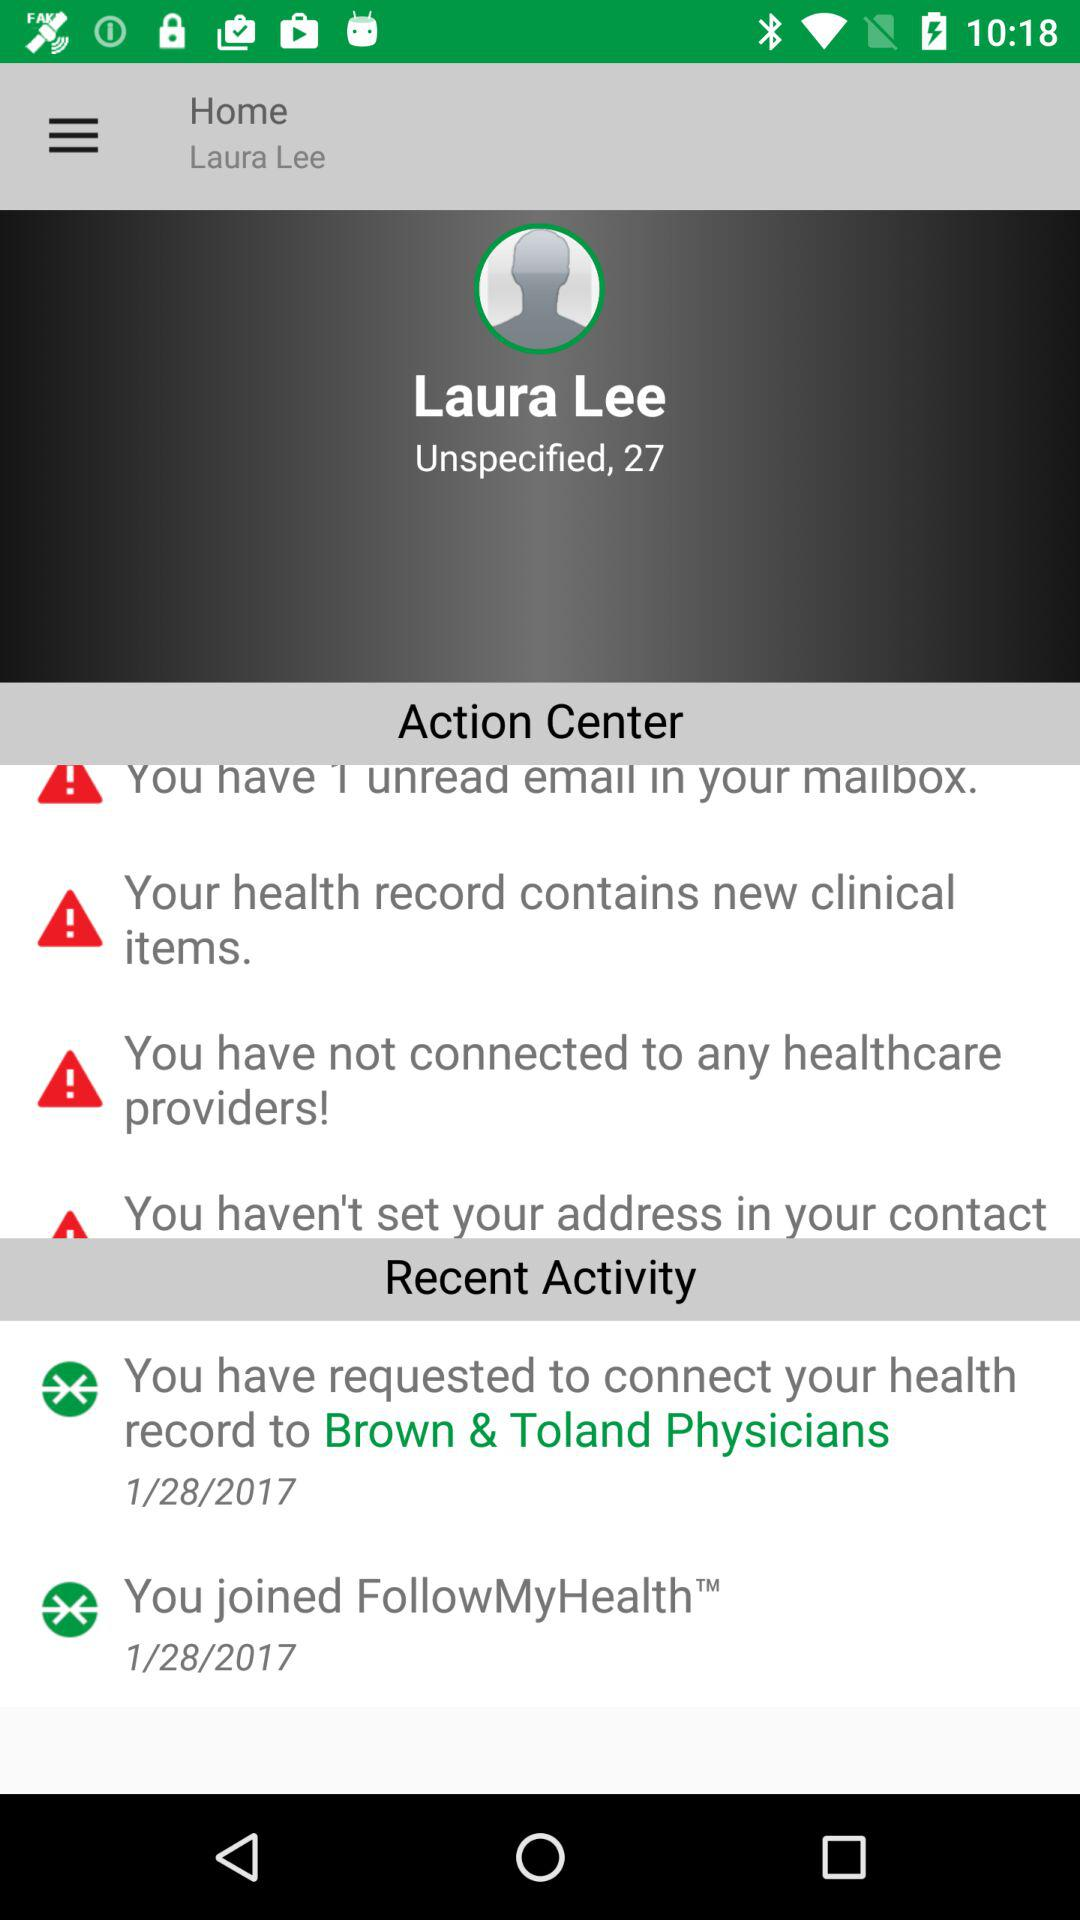How many recent activities does Laura Lee have?
Answer the question using a single word or phrase. 2 